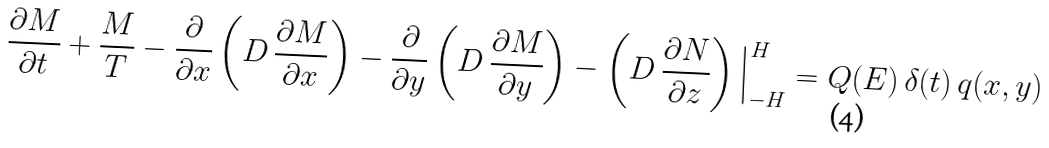<formula> <loc_0><loc_0><loc_500><loc_500>\frac { \partial M } { \partial t } + \frac { M } { T } - \frac { \partial } { \partial x } \left ( D \, \frac { \partial M } { \partial x } \right ) - \frac { \partial } { \partial y } \left ( D \, \frac { \partial M } { \partial y } \right ) - \left ( D \, \frac { \partial N } { \partial z } \right ) \Big | _ { - H } ^ { H } = Q ( E ) \, \delta ( t ) \, q ( x , y )</formula> 